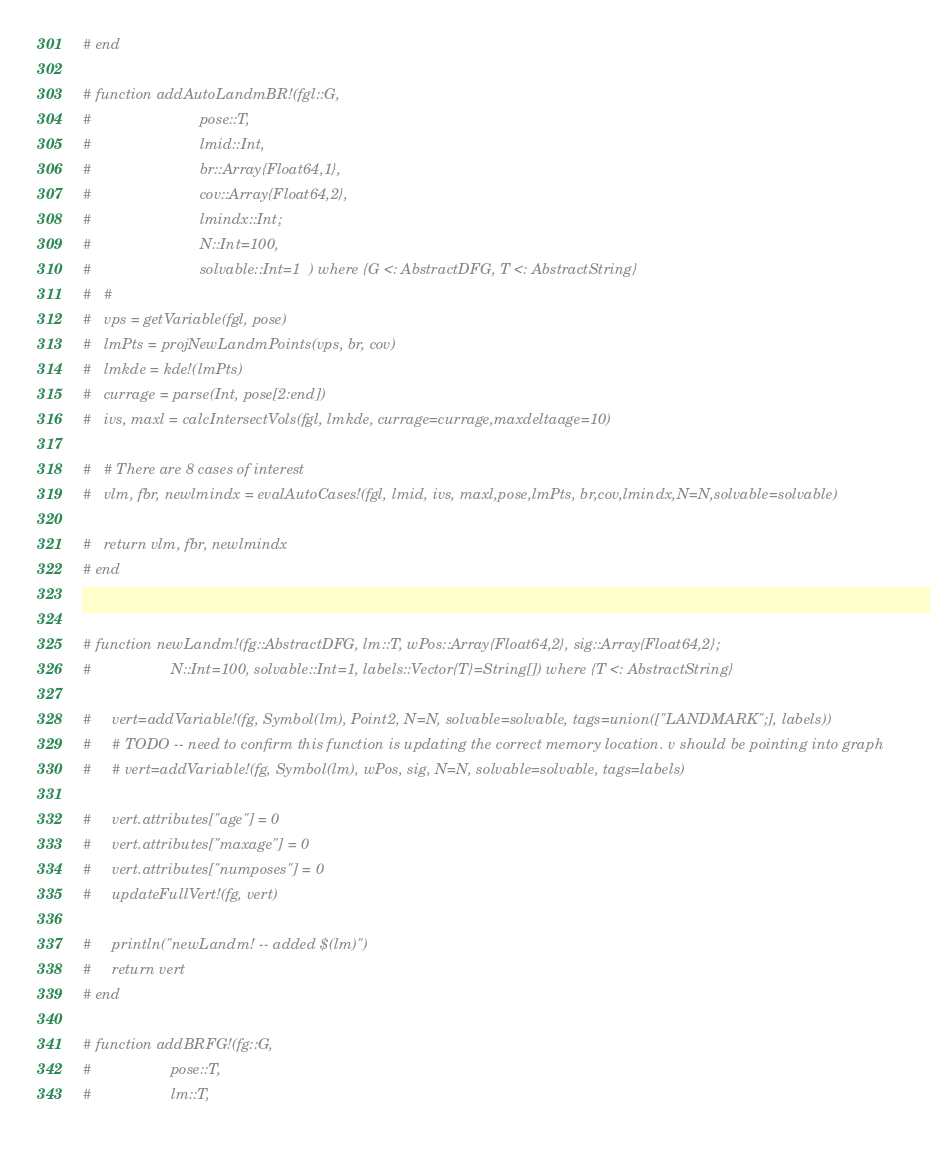Convert code to text. <code><loc_0><loc_0><loc_500><loc_500><_Julia_># end

# function addAutoLandmBR!(fgl::G,
#                          pose::T,
#                          lmid::Int,
#                          br::Array{Float64,1},
#                          cov::Array{Float64,2},
#                          lmindx::Int;
#                          N::Int=100,
#                          solvable::Int=1  ) where {G <: AbstractDFG, T <: AbstractString}
#   #
#   vps = getVariable(fgl, pose)
#   lmPts = projNewLandmPoints(vps, br, cov)
#   lmkde = kde!(lmPts)
#   currage = parse(Int, pose[2:end])
#   ivs, maxl = calcIntersectVols(fgl, lmkde, currage=currage,maxdeltaage=10)

#   # There are 8 cases of interest
#   vlm, fbr, newlmindx = evalAutoCases!(fgl, lmid, ivs, maxl,pose,lmPts, br,cov,lmindx,N=N,solvable=solvable)

#   return vlm, fbr, newlmindx
# end


# function newLandm!(fg::AbstractDFG, lm::T, wPos::Array{Float64,2}, sig::Array{Float64,2};
#                   N::Int=100, solvable::Int=1, labels::Vector{T}=String[]) where {T <: AbstractString}

#     vert=addVariable!(fg, Symbol(lm), Point2, N=N, solvable=solvable, tags=union(["LANDMARK";], labels))
#     # TODO -- need to confirm this function is updating the correct memory location. v should be pointing into graph
#     # vert=addVariable!(fg, Symbol(lm), wPos, sig, N=N, solvable=solvable, tags=labels)

#     vert.attributes["age"] = 0
#     vert.attributes["maxage"] = 0
#     vert.attributes["numposes"] = 0
#     updateFullVert!(fg, vert)

#     println("newLandm! -- added $(lm)")
#     return vert
# end

# function addBRFG!(fg::G,
#                   pose::T,
#                   lm::T,</code> 